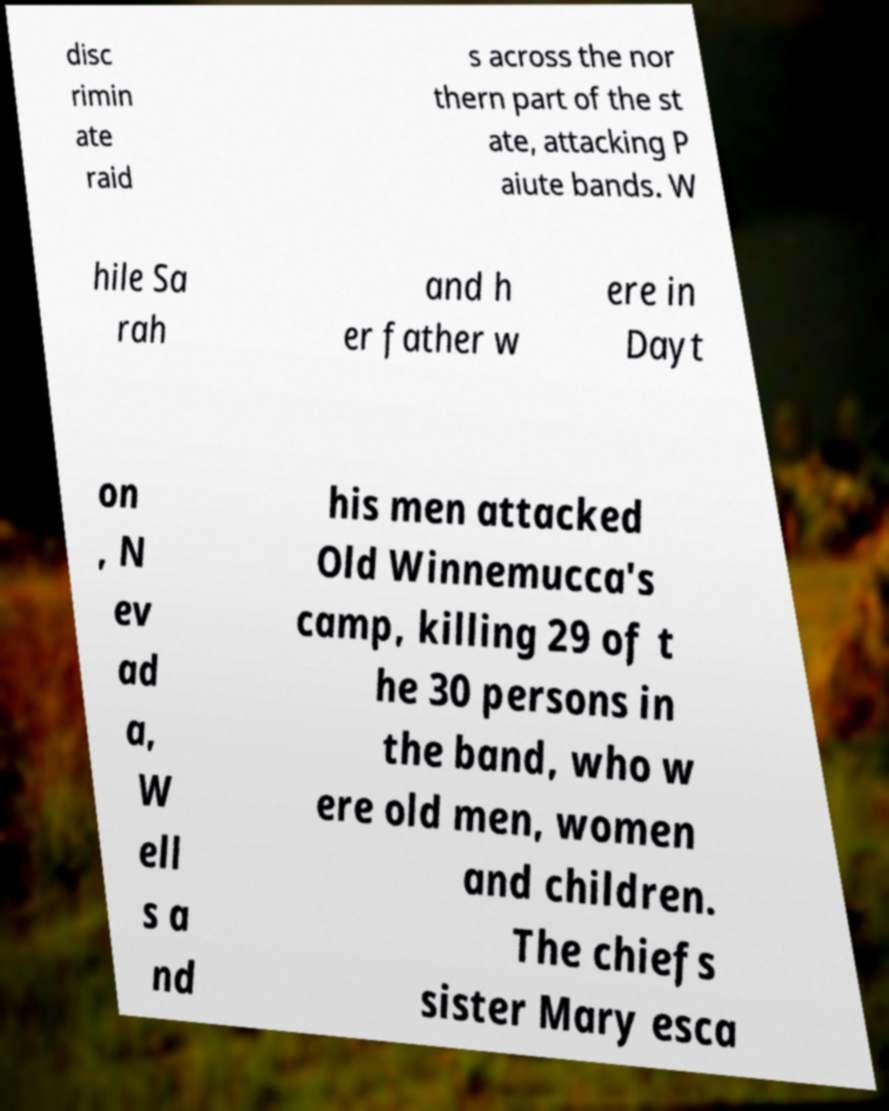Can you accurately transcribe the text from the provided image for me? disc rimin ate raid s across the nor thern part of the st ate, attacking P aiute bands. W hile Sa rah and h er father w ere in Dayt on , N ev ad a, W ell s a nd his men attacked Old Winnemucca's camp, killing 29 of t he 30 persons in the band, who w ere old men, women and children. The chiefs sister Mary esca 